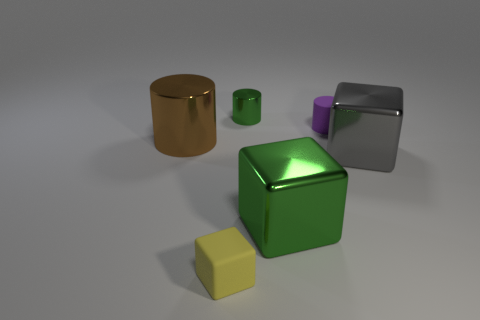Add 1 small cubes. How many objects exist? 7 Subtract all big gray rubber cubes. Subtract all small purple cylinders. How many objects are left? 5 Add 6 purple rubber cylinders. How many purple rubber cylinders are left? 7 Add 5 small purple rubber things. How many small purple rubber things exist? 6 Subtract 0 gray cylinders. How many objects are left? 6 